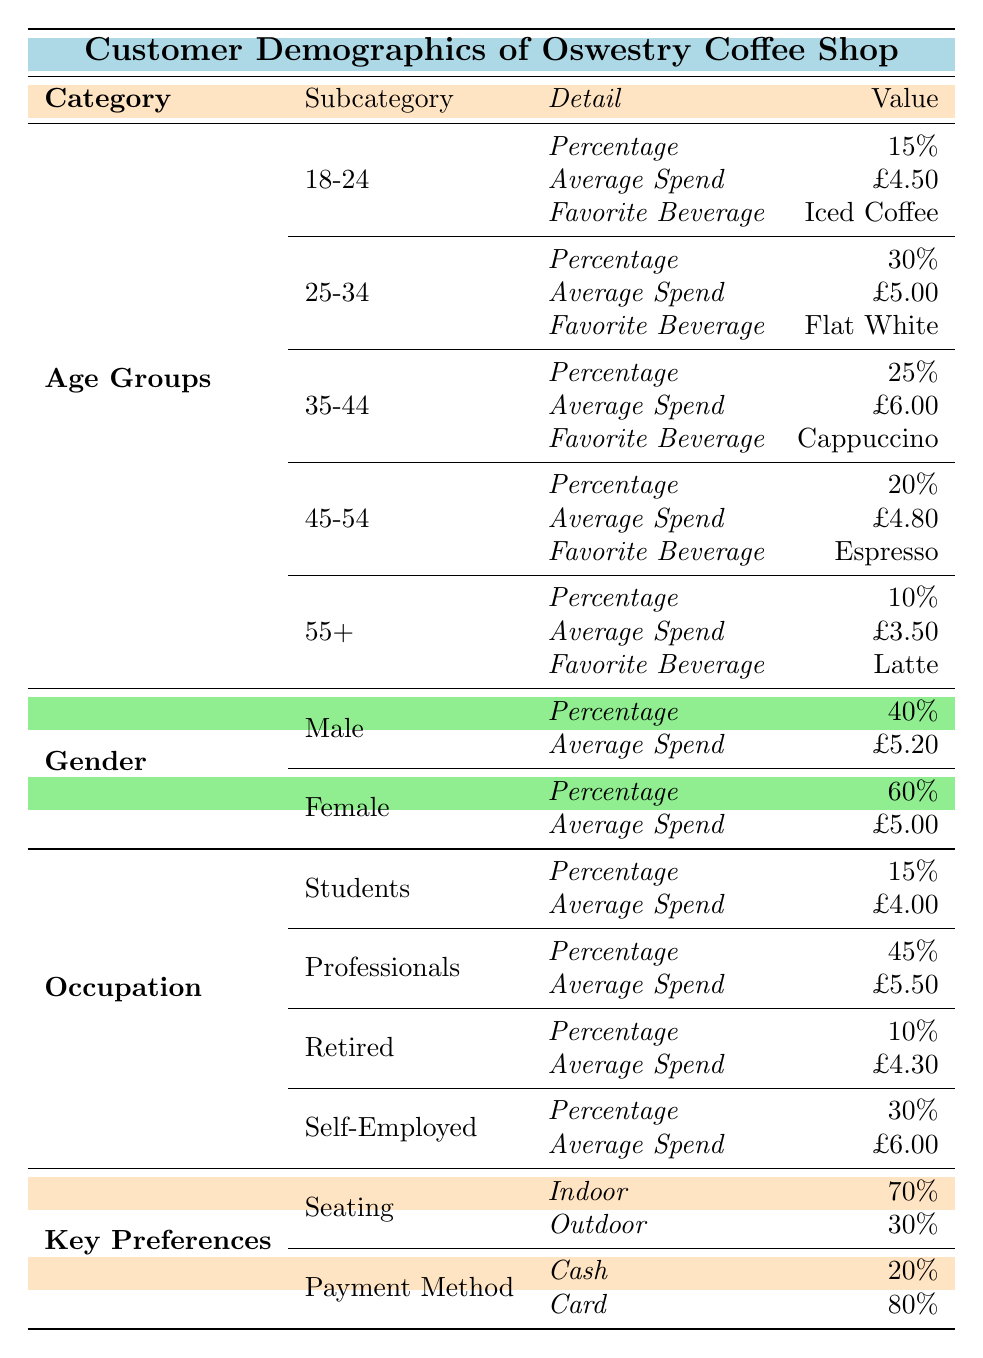What percentage of customers are aged between 25 and 34? The table shows the breakdown of age groups. For the age group 25-34, the percentage is clearly defined as 30%.
Answer: 30% What is the average spend of customers who prefer iced coffee? Under the age group 18-24, the favorite beverage is iced coffee, and their average spend is shown as £4.50.
Answer: £4.50 Which gender has a higher average spend? The average spend for males is £5.20 and for females is £5.00. Since £5.20 is greater than £5.00, it indicates that males have a higher average spend.
Answer: Yes, males have a higher average spend How much more do self-employed customers spend on average compared to students? The average spend for self-employed customers is £6.00, while for students it is £4.00. The difference is £6.00 - £4.00 = £2.00.
Answer: £2.00 What is the total percentage of customers who prefer indoor seating? The table indicates that 70% prefer indoor seating. Since there are only two choices provided, the total percentage can be taken directly from the indoor preference row.
Answer: 70% What is the average spend of the age group 45-54? In the age group 45-54, the average spend listed is £4.80 according to the table.
Answer: £4.80 Is the favorite beverage of the 55+ age group espresso? The favorite beverage for the 55+ age group is listed as latte. Therefore, the statement is false.
Answer: No What percentage of customers are retired and what is their average spend? The table shows that the retired demographic is 10% of the customers, and their average spend is £4.30.
Answer: 10%, £4.30 How many customers prefer payment by card compared to cash? From the key preferences, 80% pay by card while 20% pay by cash. To find the difference, 80% - 20% = 60%.
Answer: 60% more prefer card payment 